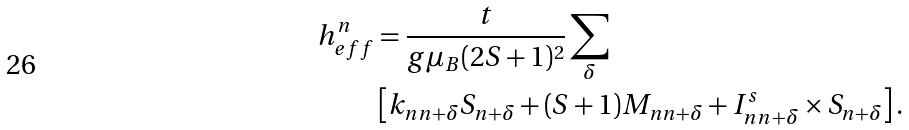<formula> <loc_0><loc_0><loc_500><loc_500>h _ { e f f } ^ { n } & = \frac { t } { g \mu _ { B } ( 2 S + 1 ) ^ { 2 } } \sum _ { \delta } \\ & \left [ k _ { n n + \delta } S _ { n + \delta } + ( S + 1 ) M _ { n n + \delta } + I _ { n n + \delta } ^ { s } \times S _ { n + \delta } \right ] .</formula> 